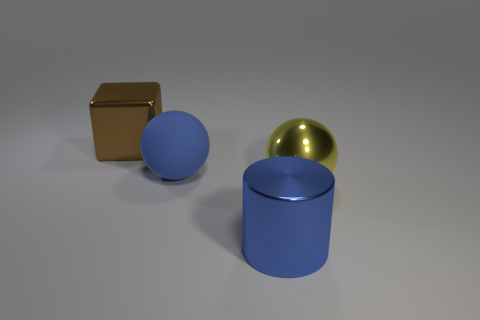Add 2 large green objects. How many objects exist? 6 Subtract all cubes. How many objects are left? 3 Subtract 0 yellow cylinders. How many objects are left? 4 Subtract all blue rubber objects. Subtract all cylinders. How many objects are left? 2 Add 2 brown objects. How many brown objects are left? 3 Add 2 rubber objects. How many rubber objects exist? 3 